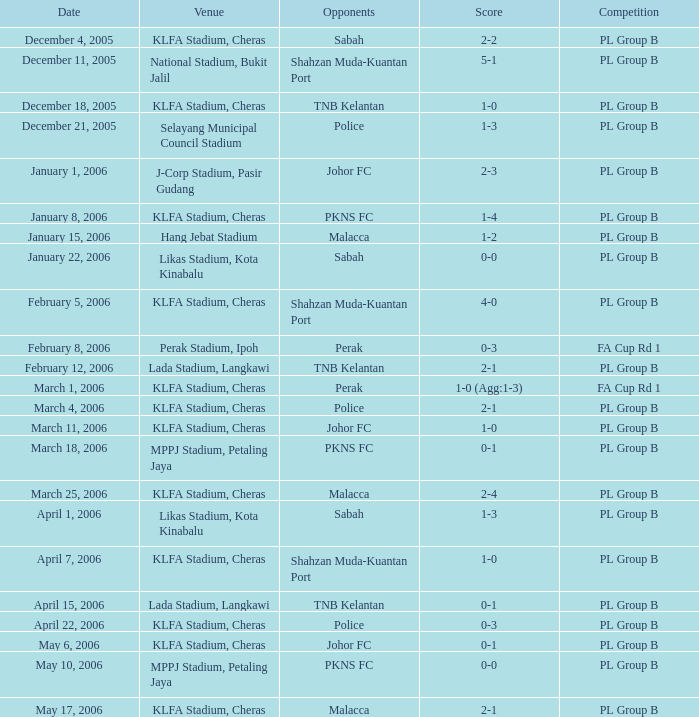Which Venue has a Competition of pl group b, and a Score of 2-2? KLFA Stadium, Cheras. 